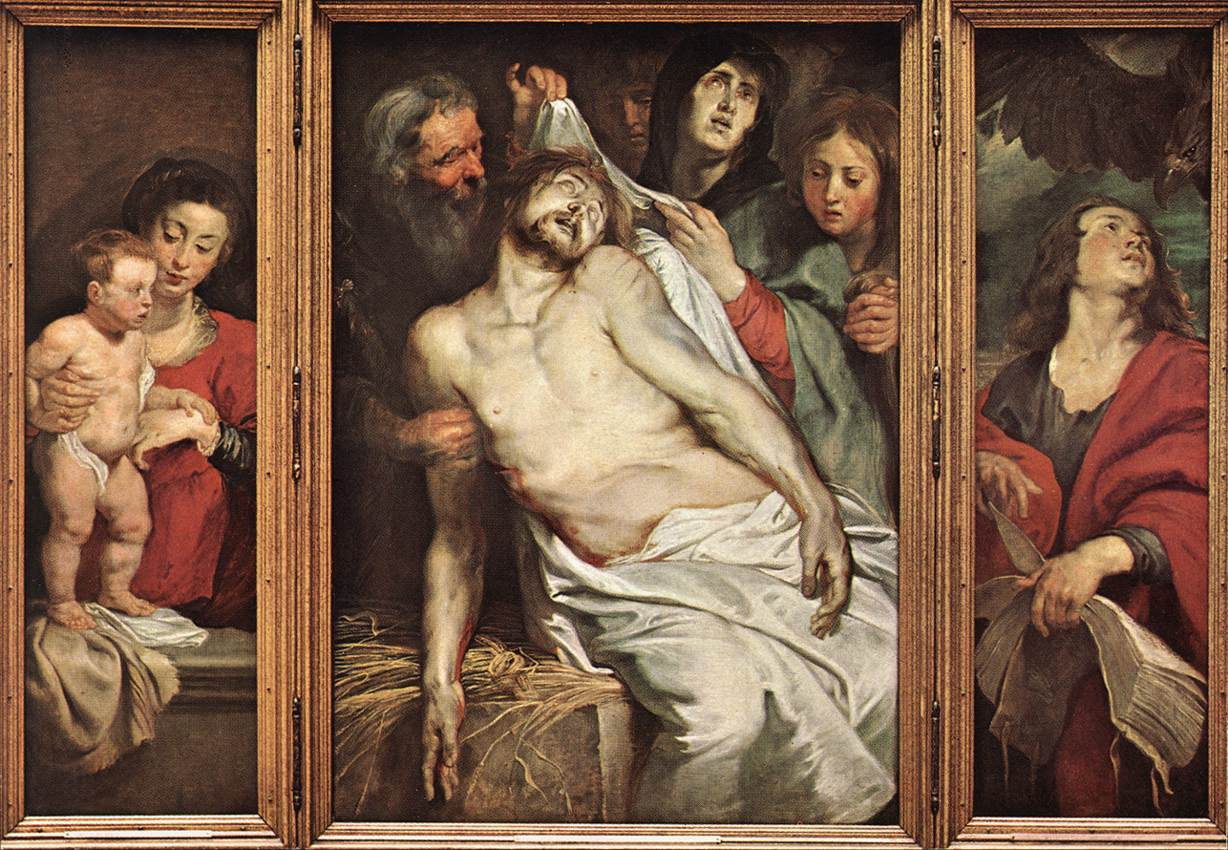Write a detailed description of the given image. The painting portrays a deeply emotional religious scene, likely from the Christian narrative of the Entombment of Christ. Central to the image is a pallid figure, draped in a white shroud, reclining with eyes closed and wounds visible, suggesting the depiction of Jesus after crucifixion. Around him, a group of mournful figures embodies varied expressions of grief and solemnity. Notable is a woman cradling a baby on the left, symbolizing Mary with Jesus' potential lineage, and a man looking upwards possibly in prayer or despair. The artist employs a triptych format, adding a structural depth to the work, with shadowing and a muted palette that enhances the mournful ambiance. This piece exemplifies the Renaissance era's focus on human emotion and religious themes, demonstrated through detailed human expressions and dynamic composition. 